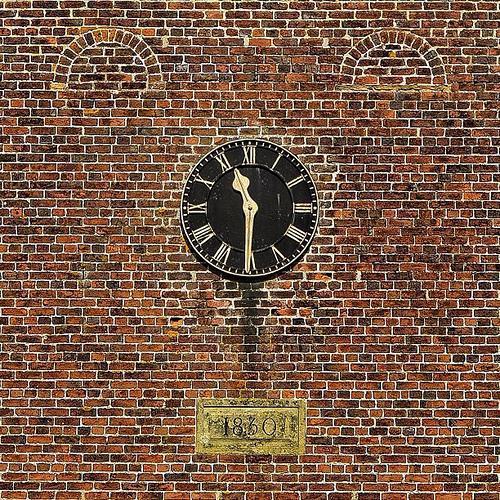How many clocks are there?
Give a very brief answer. 1. 